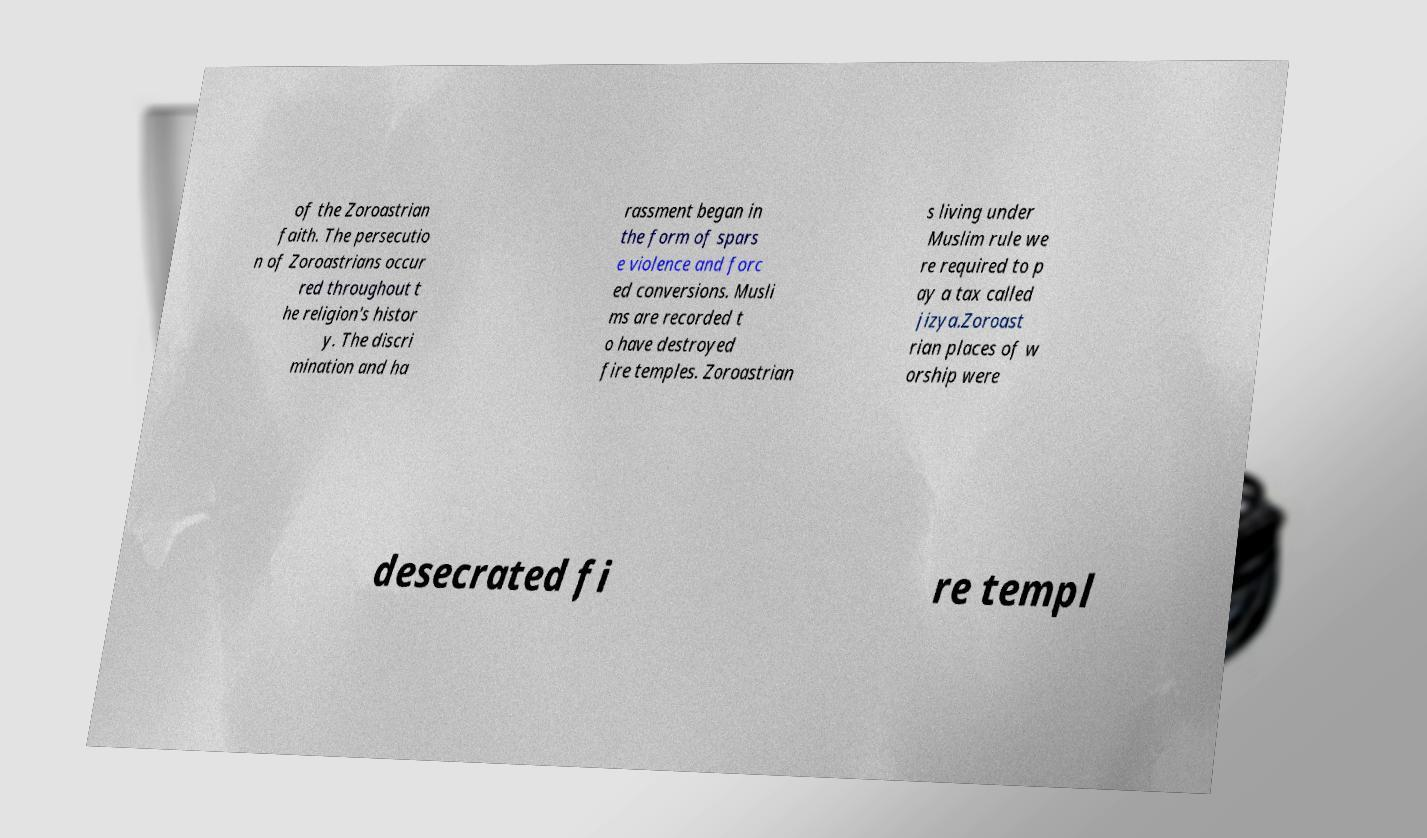Can you read and provide the text displayed in the image?This photo seems to have some interesting text. Can you extract and type it out for me? of the Zoroastrian faith. The persecutio n of Zoroastrians occur red throughout t he religion's histor y. The discri mination and ha rassment began in the form of spars e violence and forc ed conversions. Musli ms are recorded t o have destroyed fire temples. Zoroastrian s living under Muslim rule we re required to p ay a tax called jizya.Zoroast rian places of w orship were desecrated fi re templ 